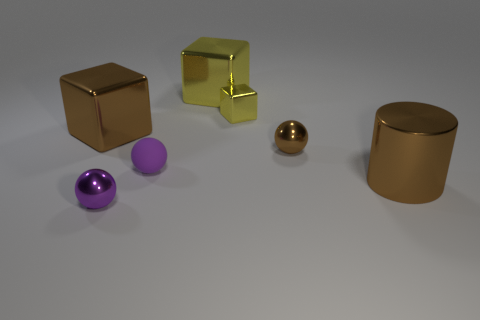Subtract all tiny yellow metal blocks. How many blocks are left? 2 Subtract all yellow cubes. How many cubes are left? 1 Add 2 tiny red metal cylinders. How many objects exist? 9 Subtract all spheres. How many objects are left? 4 Subtract all cylinders. Subtract all small brown metallic balls. How many objects are left? 5 Add 7 small yellow metal cubes. How many small yellow metal cubes are left? 8 Add 3 cubes. How many cubes exist? 6 Subtract 0 green cubes. How many objects are left? 7 Subtract 1 cubes. How many cubes are left? 2 Subtract all red blocks. Subtract all green cylinders. How many blocks are left? 3 